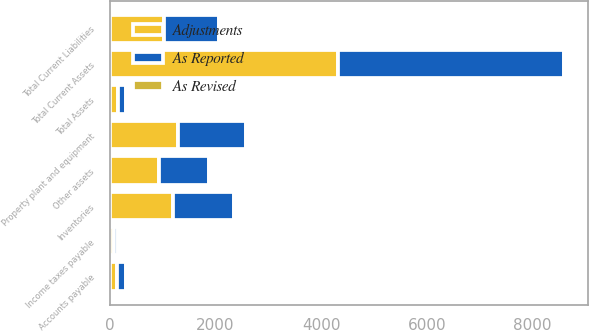Convert chart. <chart><loc_0><loc_0><loc_500><loc_500><stacked_bar_chart><ecel><fcel>Inventories<fcel>Total Current Assets<fcel>Property plant and equipment<fcel>Other assets<fcel>Total Assets<fcel>Accounts payable<fcel>Income taxes payable<fcel>Total Current Liabilities<nl><fcel>As Reported<fcel>1169<fcel>4289<fcel>1288.8<fcel>939.2<fcel>156.15<fcel>167.1<fcel>72.4<fcel>1038<nl><fcel>As Revised<fcel>24.3<fcel>24.3<fcel>3.5<fcel>2.5<fcel>23.3<fcel>21.9<fcel>7.9<fcel>14<nl><fcel>Adjustments<fcel>1193.3<fcel>4313.3<fcel>1285.3<fcel>941.7<fcel>156.15<fcel>145.2<fcel>80.3<fcel>1024<nl></chart> 